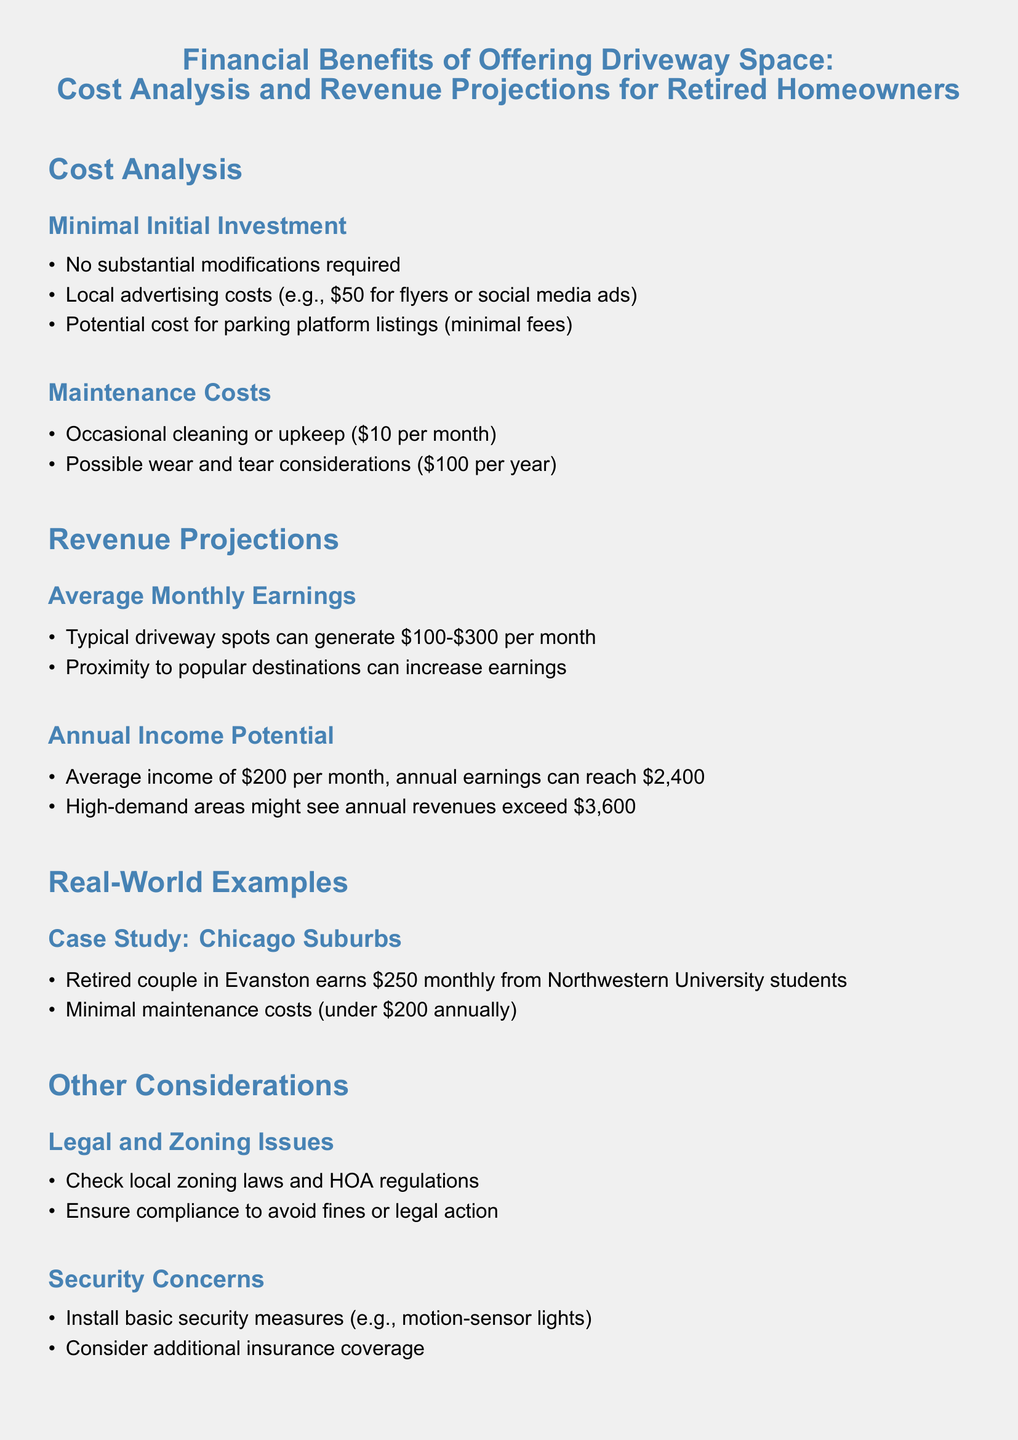what is the typical monthly earnings from a driveway spot? According to the document, typical driveway spots can generate between $100 and $300 per month.
Answer: $100-$300 what are local advertising costs mentioned? The document specifies that local advertising costs can be around $50 for flyers or social media ads.
Answer: $50 how much can average annual income potentially reach? The document states that average income of $200 per month can result in annual earnings of $2,400.
Answer: $2,400 what is the minimal maintenance cost per month? The document lists the occasional cleaning or upkeep cost as $10 per month.
Answer: $10 what are the security concerns mentioned? The document suggests installing basic security measures, such as motion-sensor lights, and considering additional insurance coverage.
Answer: Security measures and insurance what is an example of a revenue-generating case study? The document provides an example of a retired couple in Evanston earning $250 monthly from Northwestern University students.
Answer: $250 what is the potential revenue for high-demand areas annually? The document indicates that high-demand areas might see annual revenues exceeding $3,600.
Answer: Exceeding $3,600 what should homeowners check regarding legal issues? The document advises checking local zoning laws and HOA regulations to ensure compliance.
Answer: Local zoning laws how much might annual maintenance costs sum to? The document states that minimal maintenance costs can total under $200 annually.
Answer: Under $200 